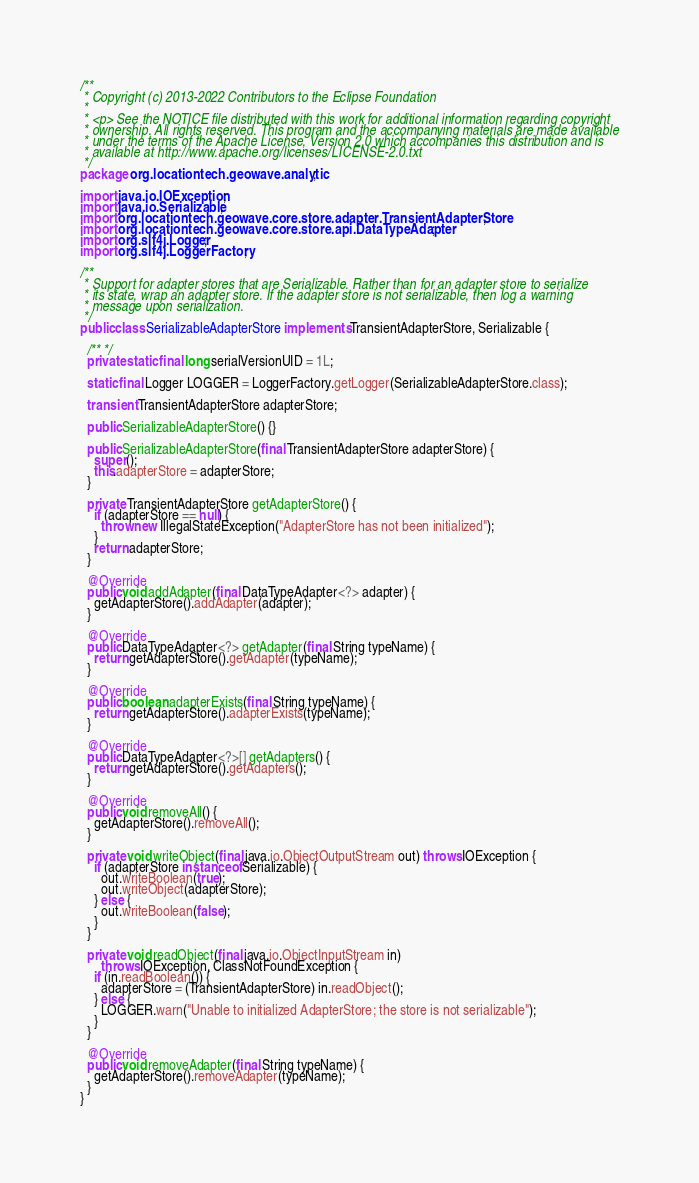<code> <loc_0><loc_0><loc_500><loc_500><_Java_>/**
 * Copyright (c) 2013-2022 Contributors to the Eclipse Foundation
 *
 * <p> See the NOTICE file distributed with this work for additional information regarding copyright
 * ownership. All rights reserved. This program and the accompanying materials are made available
 * under the terms of the Apache License, Version 2.0 which accompanies this distribution and is
 * available at http://www.apache.org/licenses/LICENSE-2.0.txt
 */
package org.locationtech.geowave.analytic;

import java.io.IOException;
import java.io.Serializable;
import org.locationtech.geowave.core.store.adapter.TransientAdapterStore;
import org.locationtech.geowave.core.store.api.DataTypeAdapter;
import org.slf4j.Logger;
import org.slf4j.LoggerFactory;

/**
 * Support for adapter stores that are Serializable. Rather than for an adapter store to serialize
 * its state, wrap an adapter store. If the adapter store is not serializable, then log a warning
 * message upon serialization.
 */
public class SerializableAdapterStore implements TransientAdapterStore, Serializable {

  /** */
  private static final long serialVersionUID = 1L;

  static final Logger LOGGER = LoggerFactory.getLogger(SerializableAdapterStore.class);

  transient TransientAdapterStore adapterStore;

  public SerializableAdapterStore() {}

  public SerializableAdapterStore(final TransientAdapterStore adapterStore) {
    super();
    this.adapterStore = adapterStore;
  }

  private TransientAdapterStore getAdapterStore() {
    if (adapterStore == null) {
      throw new IllegalStateException("AdapterStore has not been initialized");
    }
    return adapterStore;
  }

  @Override
  public void addAdapter(final DataTypeAdapter<?> adapter) {
    getAdapterStore().addAdapter(adapter);
  }

  @Override
  public DataTypeAdapter<?> getAdapter(final String typeName) {
    return getAdapterStore().getAdapter(typeName);
  }

  @Override
  public boolean adapterExists(final String typeName) {
    return getAdapterStore().adapterExists(typeName);
  }

  @Override
  public DataTypeAdapter<?>[] getAdapters() {
    return getAdapterStore().getAdapters();
  }

  @Override
  public void removeAll() {
    getAdapterStore().removeAll();
  }

  private void writeObject(final java.io.ObjectOutputStream out) throws IOException {
    if (adapterStore instanceof Serializable) {
      out.writeBoolean(true);
      out.writeObject(adapterStore);
    } else {
      out.writeBoolean(false);
    }
  }

  private void readObject(final java.io.ObjectInputStream in)
      throws IOException, ClassNotFoundException {
    if (in.readBoolean()) {
      adapterStore = (TransientAdapterStore) in.readObject();
    } else {
      LOGGER.warn("Unable to initialized AdapterStore; the store is not serializable");
    }
  }

  @Override
  public void removeAdapter(final String typeName) {
    getAdapterStore().removeAdapter(typeName);
  }
}
</code> 